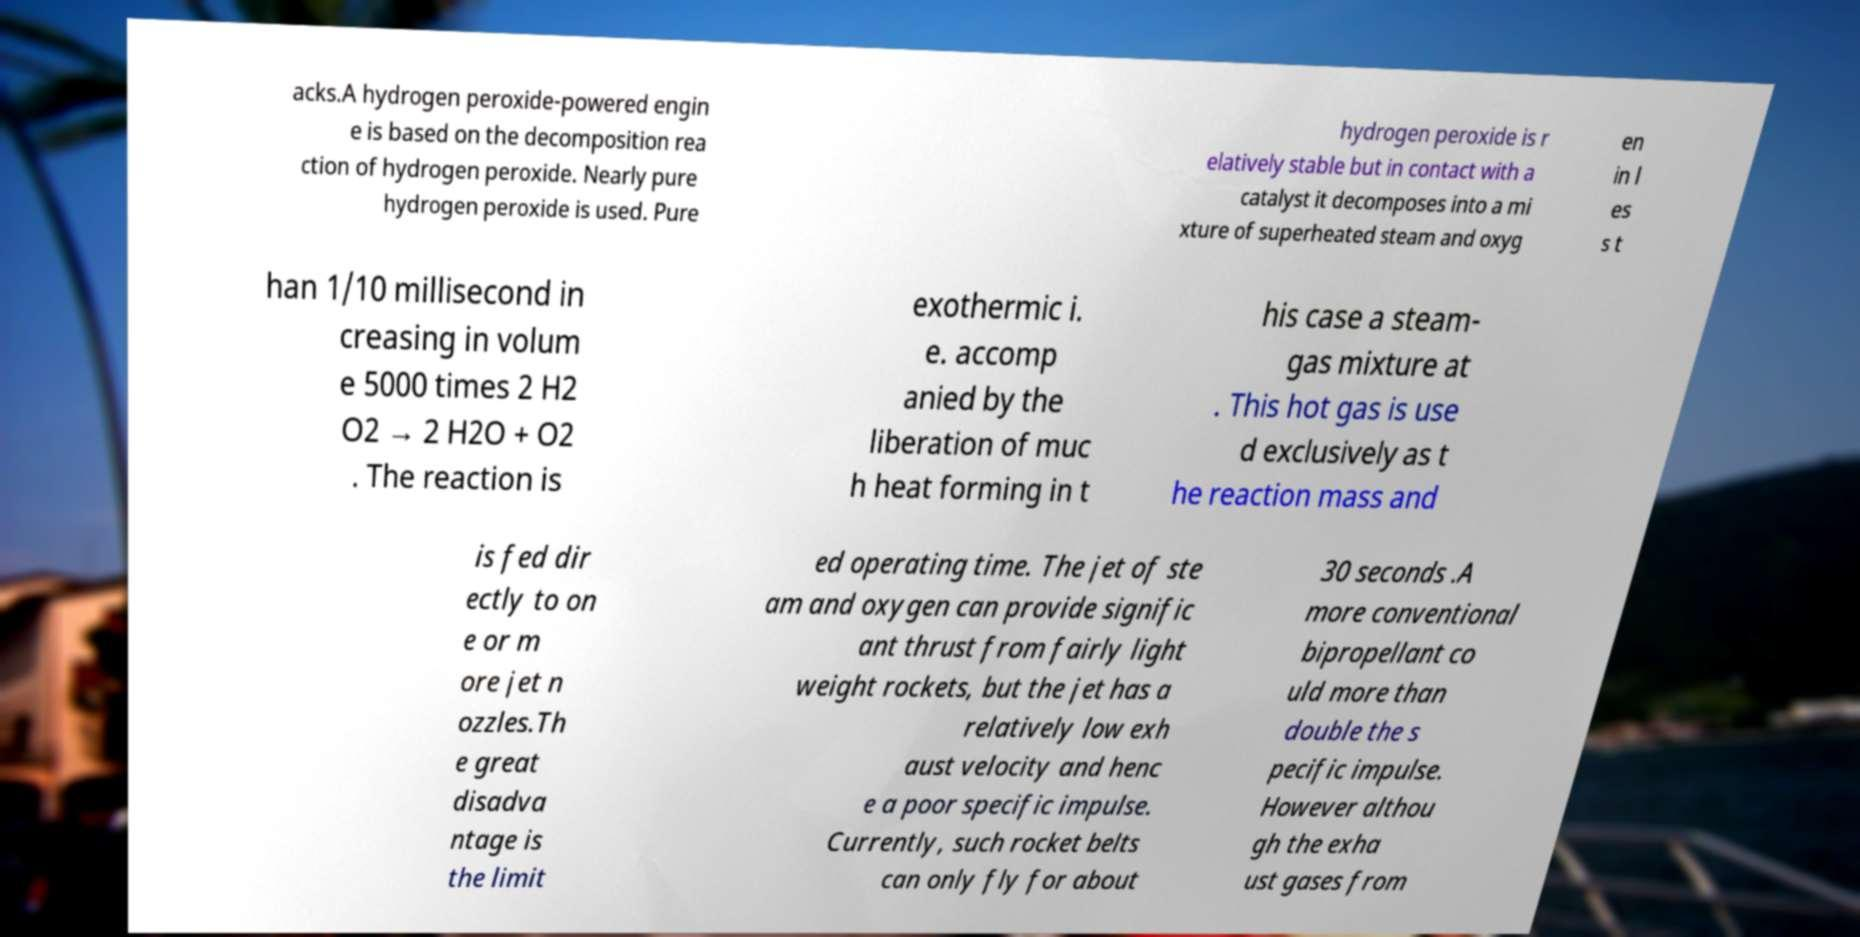For documentation purposes, I need the text within this image transcribed. Could you provide that? acks.A hydrogen peroxide-powered engin e is based on the decomposition rea ction of hydrogen peroxide. Nearly pure hydrogen peroxide is used. Pure hydrogen peroxide is r elatively stable but in contact with a catalyst it decomposes into a mi xture of superheated steam and oxyg en in l es s t han 1/10 millisecond in creasing in volum e 5000 times 2 H2 O2 → 2 H2O + O2 . The reaction is exothermic i. e. accomp anied by the liberation of muc h heat forming in t his case a steam- gas mixture at . This hot gas is use d exclusively as t he reaction mass and is fed dir ectly to on e or m ore jet n ozzles.Th e great disadva ntage is the limit ed operating time. The jet of ste am and oxygen can provide signific ant thrust from fairly light weight rockets, but the jet has a relatively low exh aust velocity and henc e a poor specific impulse. Currently, such rocket belts can only fly for about 30 seconds .A more conventional bipropellant co uld more than double the s pecific impulse. However althou gh the exha ust gases from 